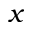<formula> <loc_0><loc_0><loc_500><loc_500>x</formula> 